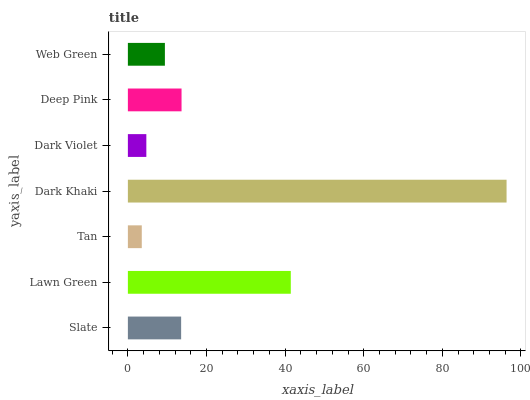Is Tan the minimum?
Answer yes or no. Yes. Is Dark Khaki the maximum?
Answer yes or no. Yes. Is Lawn Green the minimum?
Answer yes or no. No. Is Lawn Green the maximum?
Answer yes or no. No. Is Lawn Green greater than Slate?
Answer yes or no. Yes. Is Slate less than Lawn Green?
Answer yes or no. Yes. Is Slate greater than Lawn Green?
Answer yes or no. No. Is Lawn Green less than Slate?
Answer yes or no. No. Is Slate the high median?
Answer yes or no. Yes. Is Slate the low median?
Answer yes or no. Yes. Is Tan the high median?
Answer yes or no. No. Is Deep Pink the low median?
Answer yes or no. No. 